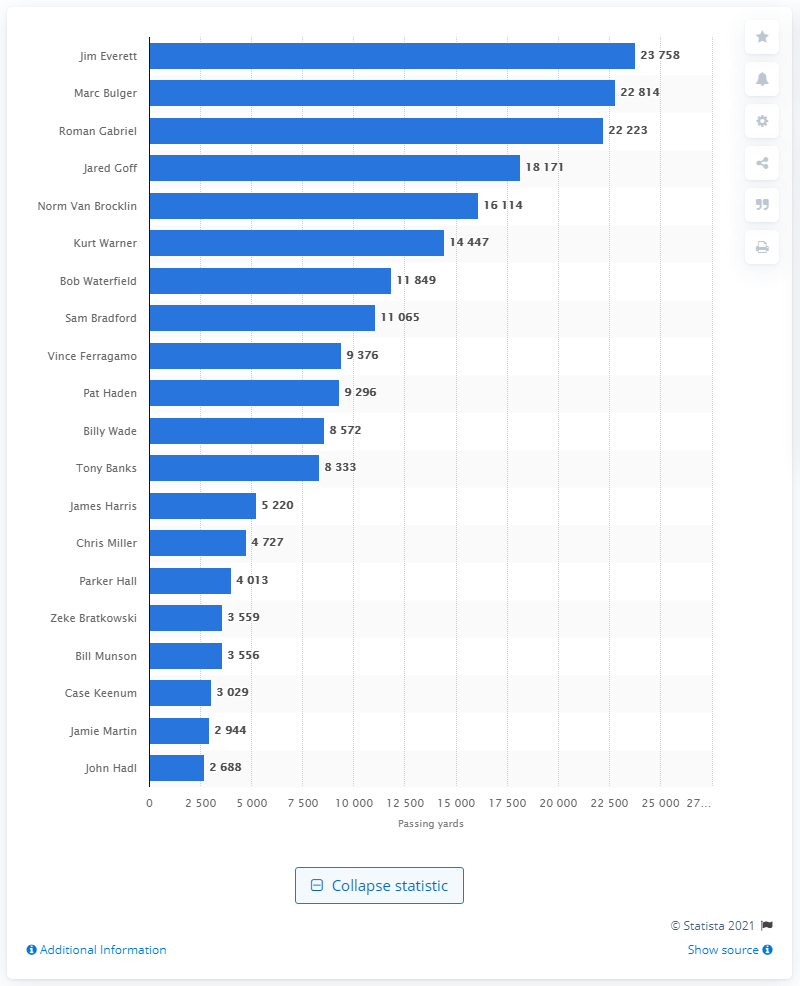List a handful of essential elements in this visual. The individual who holds the record for most career passing yards for the Los Angeles Rams is Jim Everett. 